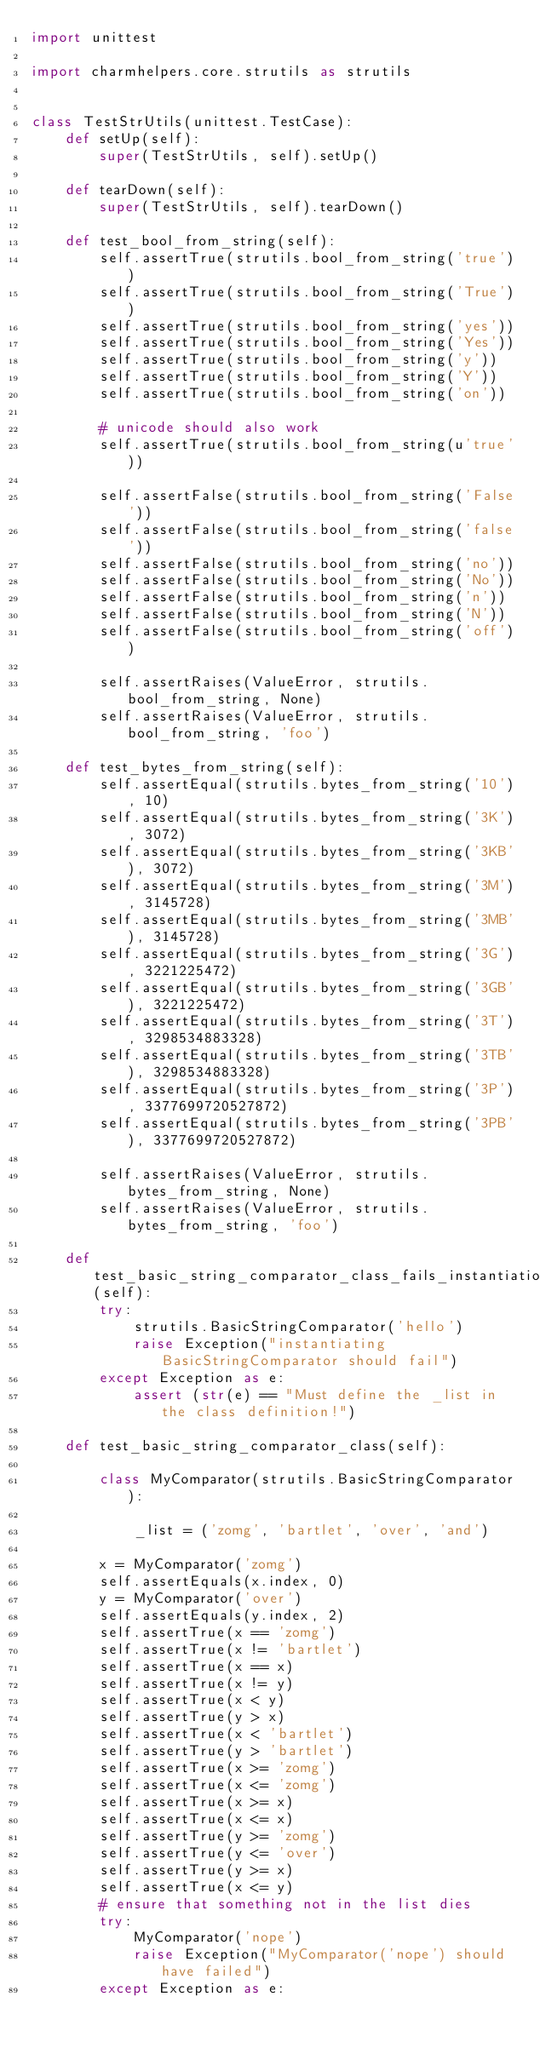<code> <loc_0><loc_0><loc_500><loc_500><_Python_>import unittest

import charmhelpers.core.strutils as strutils


class TestStrUtils(unittest.TestCase):
    def setUp(self):
        super(TestStrUtils, self).setUp()

    def tearDown(self):
        super(TestStrUtils, self).tearDown()

    def test_bool_from_string(self):
        self.assertTrue(strutils.bool_from_string('true'))
        self.assertTrue(strutils.bool_from_string('True'))
        self.assertTrue(strutils.bool_from_string('yes'))
        self.assertTrue(strutils.bool_from_string('Yes'))
        self.assertTrue(strutils.bool_from_string('y'))
        self.assertTrue(strutils.bool_from_string('Y'))
        self.assertTrue(strutils.bool_from_string('on'))

        # unicode should also work
        self.assertTrue(strutils.bool_from_string(u'true'))

        self.assertFalse(strutils.bool_from_string('False'))
        self.assertFalse(strutils.bool_from_string('false'))
        self.assertFalse(strutils.bool_from_string('no'))
        self.assertFalse(strutils.bool_from_string('No'))
        self.assertFalse(strutils.bool_from_string('n'))
        self.assertFalse(strutils.bool_from_string('N'))
        self.assertFalse(strutils.bool_from_string('off'))

        self.assertRaises(ValueError, strutils.bool_from_string, None)
        self.assertRaises(ValueError, strutils.bool_from_string, 'foo')

    def test_bytes_from_string(self):
        self.assertEqual(strutils.bytes_from_string('10'), 10)
        self.assertEqual(strutils.bytes_from_string('3K'), 3072)
        self.assertEqual(strutils.bytes_from_string('3KB'), 3072)
        self.assertEqual(strutils.bytes_from_string('3M'), 3145728)
        self.assertEqual(strutils.bytes_from_string('3MB'), 3145728)
        self.assertEqual(strutils.bytes_from_string('3G'), 3221225472)
        self.assertEqual(strutils.bytes_from_string('3GB'), 3221225472)
        self.assertEqual(strutils.bytes_from_string('3T'), 3298534883328)
        self.assertEqual(strutils.bytes_from_string('3TB'), 3298534883328)
        self.assertEqual(strutils.bytes_from_string('3P'), 3377699720527872)
        self.assertEqual(strutils.bytes_from_string('3PB'), 3377699720527872)

        self.assertRaises(ValueError, strutils.bytes_from_string, None)
        self.assertRaises(ValueError, strutils.bytes_from_string, 'foo')

    def test_basic_string_comparator_class_fails_instantiation(self):
        try:
            strutils.BasicStringComparator('hello')
            raise Exception("instantiating BasicStringComparator should fail")
        except Exception as e:
            assert (str(e) == "Must define the _list in the class definition!")

    def test_basic_string_comparator_class(self):

        class MyComparator(strutils.BasicStringComparator):

            _list = ('zomg', 'bartlet', 'over', 'and')

        x = MyComparator('zomg')
        self.assertEquals(x.index, 0)
        y = MyComparator('over')
        self.assertEquals(y.index, 2)
        self.assertTrue(x == 'zomg')
        self.assertTrue(x != 'bartlet')
        self.assertTrue(x == x)
        self.assertTrue(x != y)
        self.assertTrue(x < y)
        self.assertTrue(y > x)
        self.assertTrue(x < 'bartlet')
        self.assertTrue(y > 'bartlet')
        self.assertTrue(x >= 'zomg')
        self.assertTrue(x <= 'zomg')
        self.assertTrue(x >= x)
        self.assertTrue(x <= x)
        self.assertTrue(y >= 'zomg')
        self.assertTrue(y <= 'over')
        self.assertTrue(y >= x)
        self.assertTrue(x <= y)
        # ensure that something not in the list dies
        try:
            MyComparator('nope')
            raise Exception("MyComparator('nope') should have failed")
        except Exception as e:</code> 